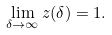<formula> <loc_0><loc_0><loc_500><loc_500>\lim _ { \delta \to \infty } z ( \delta ) = 1 .</formula> 